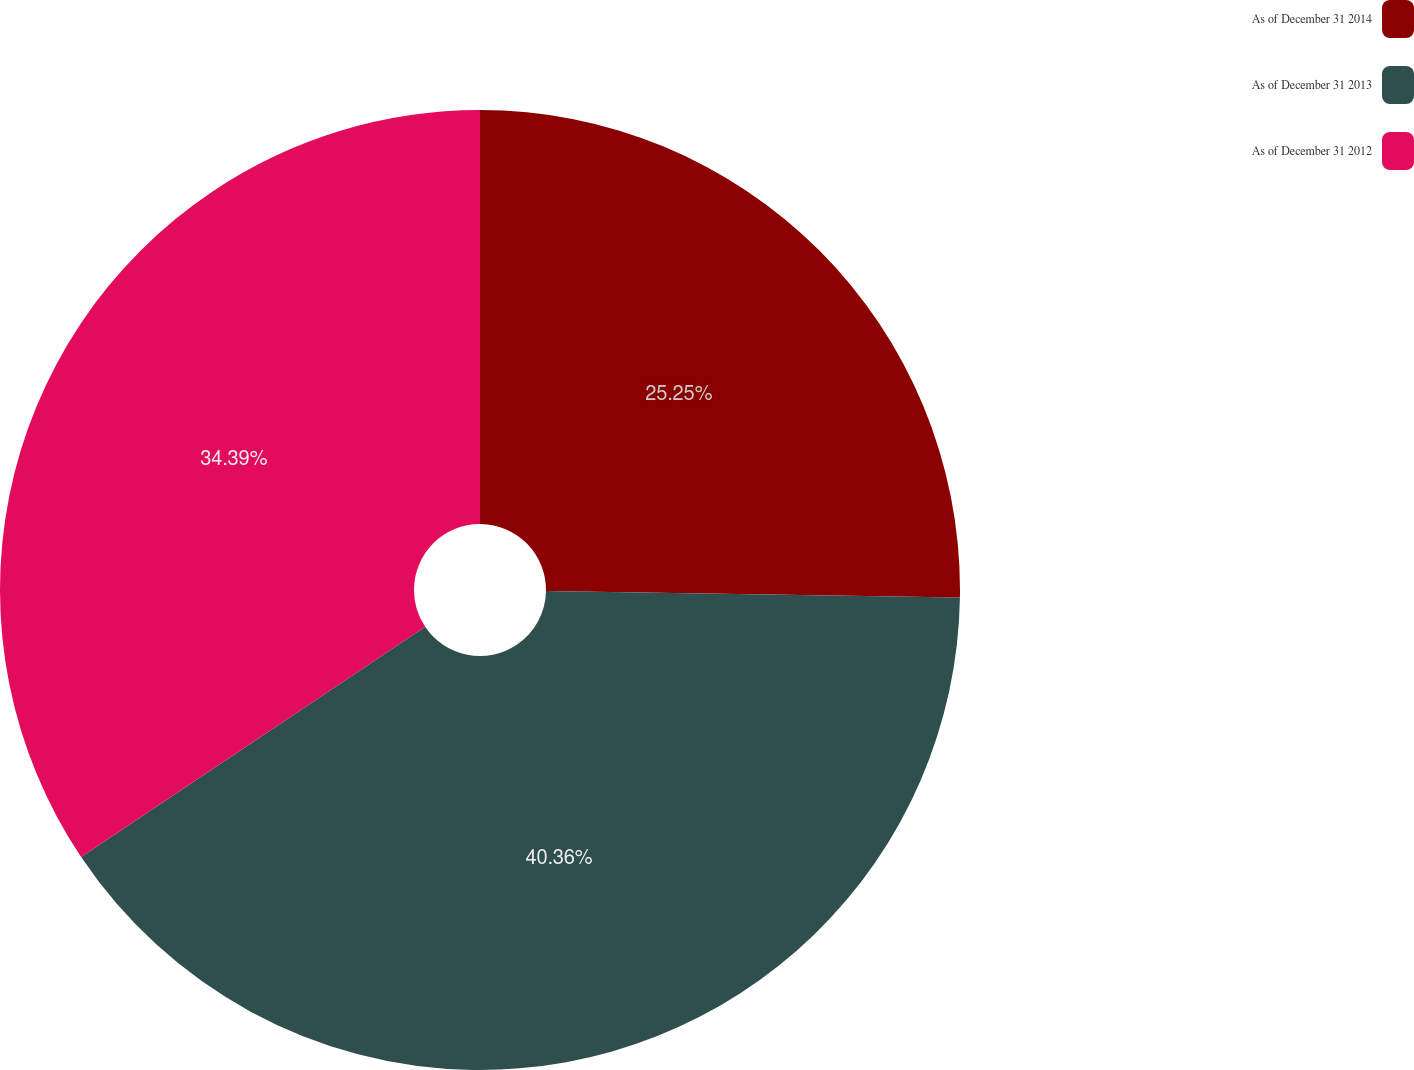Convert chart to OTSL. <chart><loc_0><loc_0><loc_500><loc_500><pie_chart><fcel>As of December 31 2014<fcel>As of December 31 2013<fcel>As of December 31 2012<nl><fcel>25.25%<fcel>40.36%<fcel>34.39%<nl></chart> 